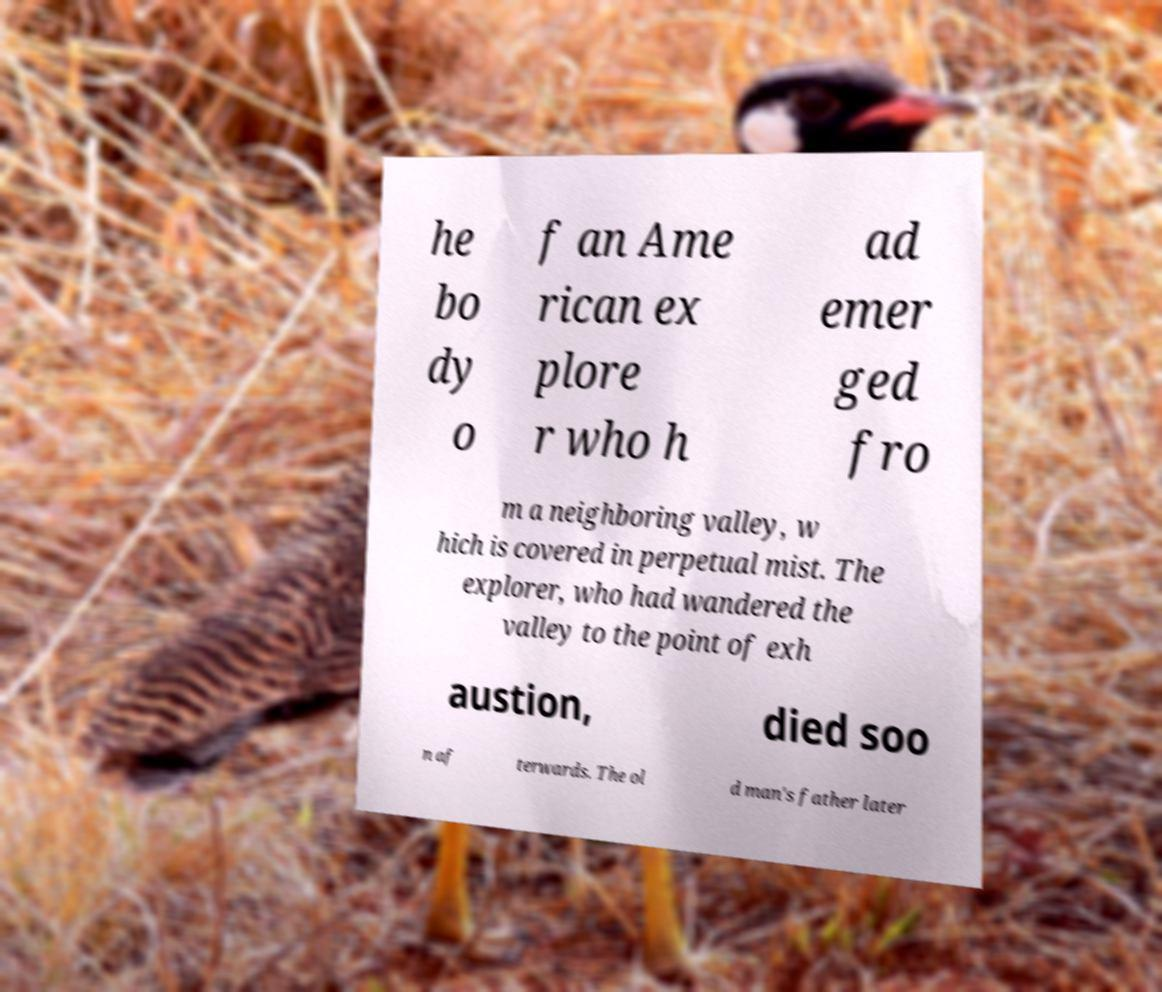Could you assist in decoding the text presented in this image and type it out clearly? he bo dy o f an Ame rican ex plore r who h ad emer ged fro m a neighboring valley, w hich is covered in perpetual mist. The explorer, who had wandered the valley to the point of exh austion, died soo n af terwards. The ol d man's father later 